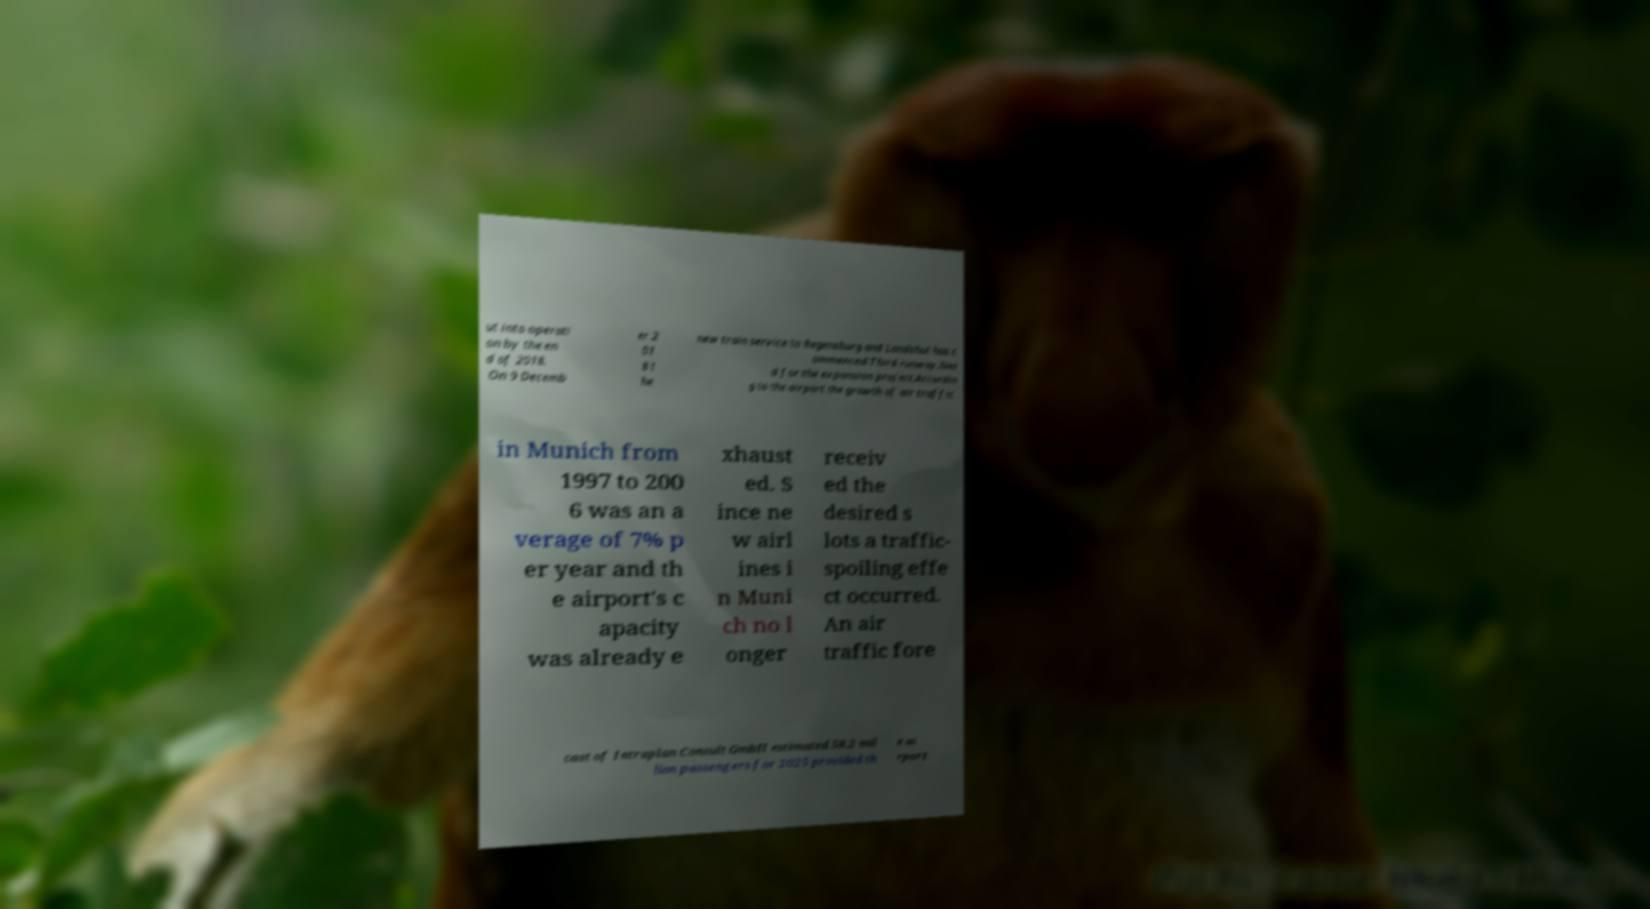Please read and relay the text visible in this image. What does it say? ut into operati on by the en d of 2018. On 9 Decemb er 2 01 8 t he new train service to Regensburg and Landshut has c ommenced.Third runway.Nee d for the expansion project.Accordin g to the airport the growth of air traffic in Munich from 1997 to 200 6 was an a verage of 7% p er year and th e airport's c apacity was already e xhaust ed. S ince ne w airl ines i n Muni ch no l onger receiv ed the desired s lots a traffic- spoiling effe ct occurred. An air traffic fore cast of Intraplan Consult GmbH estimated 58.2 mil lion passengers for 2025 provided th e ai rport 